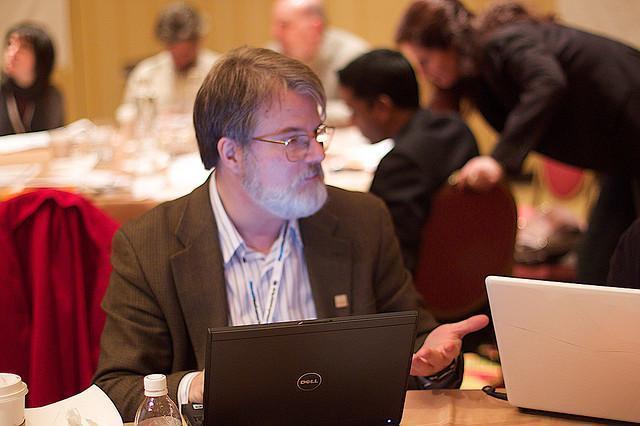How many laptops are in the photo?
Give a very brief answer. 2. How many chairs are there?
Give a very brief answer. 2. How many people are in the picture?
Give a very brief answer. 6. How many dining tables can you see?
Give a very brief answer. 2. 